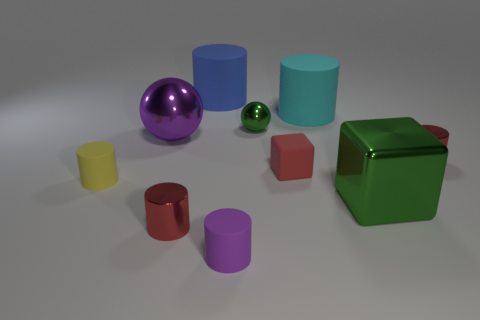Are the tiny ball and the big cylinder that is behind the large cyan cylinder made of the same material?
Offer a terse response. No. What number of other objects are there of the same size as the red block?
Offer a terse response. 5. Is there a small cylinder that is to the left of the red metallic cylinder to the left of the cylinder that is behind the large cyan cylinder?
Your answer should be very brief. Yes. What is the size of the yellow object?
Offer a terse response. Small. There is a rubber cylinder to the right of the tiny green sphere; what size is it?
Your response must be concise. Large. Is the size of the red cylinder left of the green sphere the same as the large cyan rubber object?
Your answer should be compact. No. Is there any other thing of the same color as the big ball?
Your answer should be very brief. Yes. What shape is the big green object?
Your answer should be compact. Cube. What number of things are on the left side of the large cyan matte thing and in front of the big cyan cylinder?
Your answer should be very brief. 6. Does the large shiny cube have the same color as the small sphere?
Give a very brief answer. Yes. 